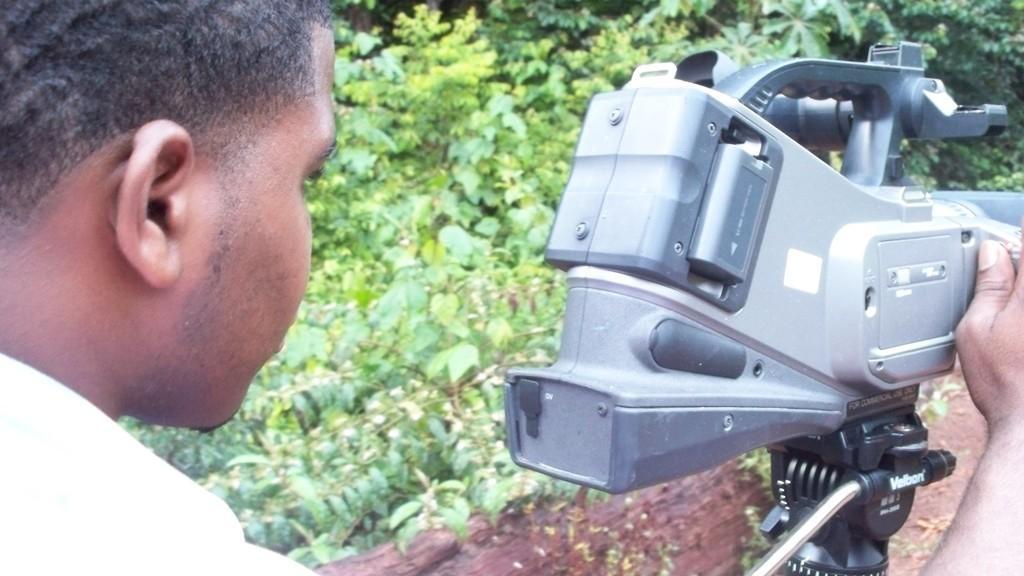Can you describe this image briefly? in this image on the left there is a man he is holding a machine. In the background there are many plants. 